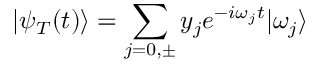Convert formula to latex. <formula><loc_0><loc_0><loc_500><loc_500>| \psi _ { T } ( t ) \rangle = \sum _ { \substack { j = 0 , \pm } } y _ { j } e ^ { - i \omega _ { j } t } | \omega _ { j } \rangle</formula> 